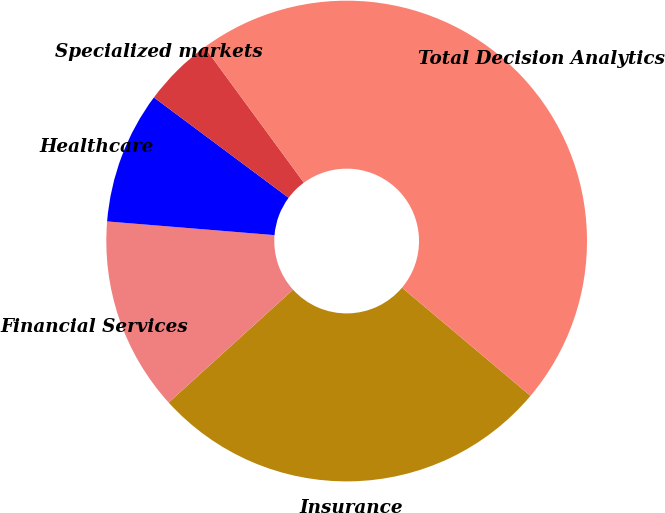Convert chart to OTSL. <chart><loc_0><loc_0><loc_500><loc_500><pie_chart><fcel>Insurance<fcel>Financial Services<fcel>Healthcare<fcel>Specialized markets<fcel>Total Decision Analytics<nl><fcel>27.13%<fcel>13.03%<fcel>8.89%<fcel>4.74%<fcel>46.21%<nl></chart> 